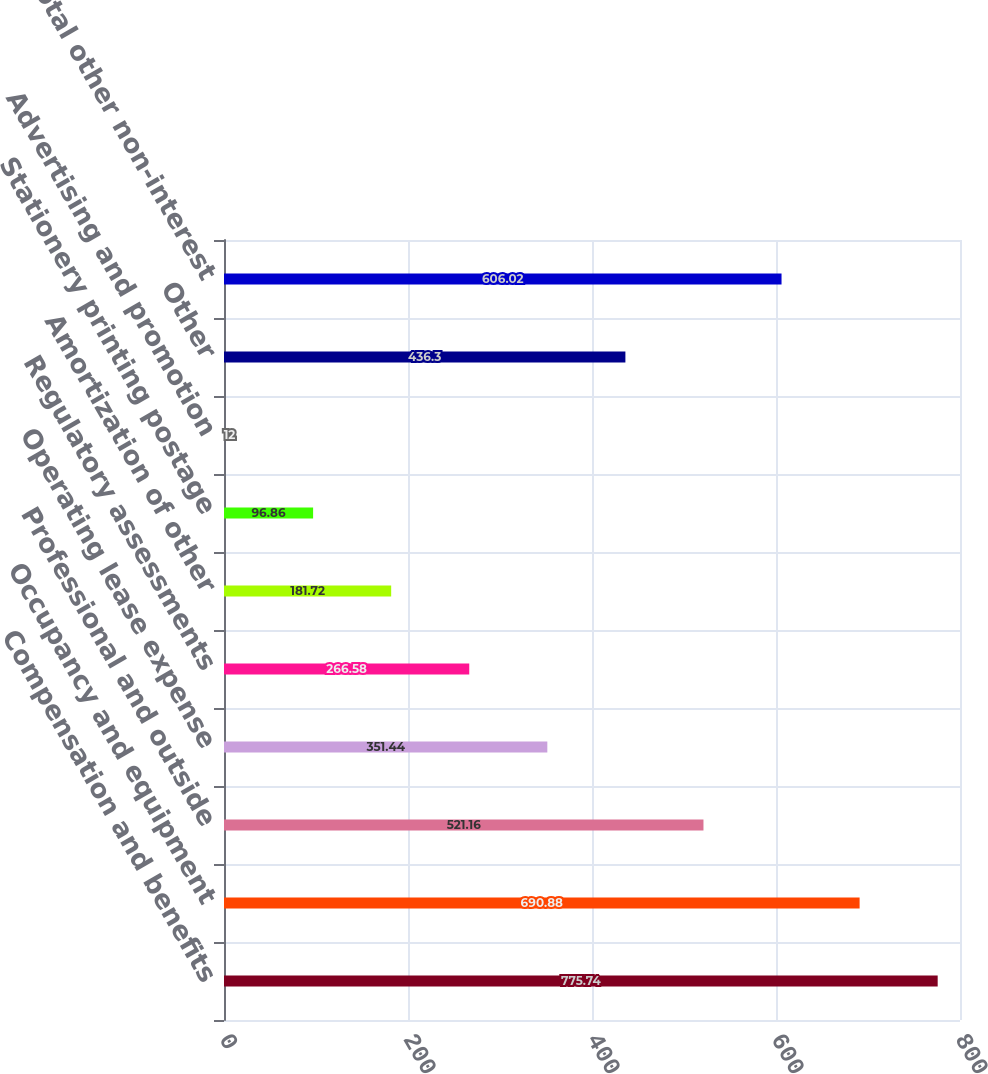Convert chart to OTSL. <chart><loc_0><loc_0><loc_500><loc_500><bar_chart><fcel>Compensation and benefits<fcel>Occupancy and equipment<fcel>Professional and outside<fcel>Operating lease expense<fcel>Regulatory assessments<fcel>Amortization of other<fcel>Stationery printing postage<fcel>Advertising and promotion<fcel>Other<fcel>Total other non-interest<nl><fcel>775.74<fcel>690.88<fcel>521.16<fcel>351.44<fcel>266.58<fcel>181.72<fcel>96.86<fcel>12<fcel>436.3<fcel>606.02<nl></chart> 